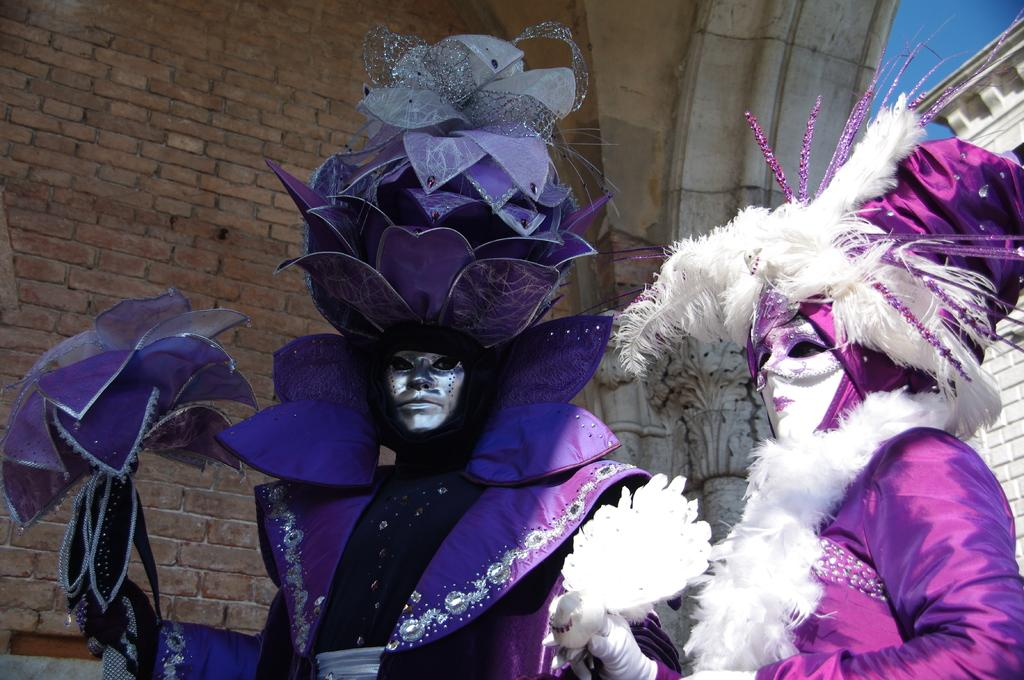What are the people in the foreground of the image wearing? The persons in the foreground of the image are wearing carnival costumes and masks. What can be seen in the background of the image? There is a brick wall and a building in the background of the image. What is visible in the sky in the background of the image? The sky is visible in the background of the image. What type of ship can be seen sailing in the background of the image? There is no ship present in the image; it features persons wearing carnival costumes and masks in the foreground and a brick wall, building, and sky in the background. 